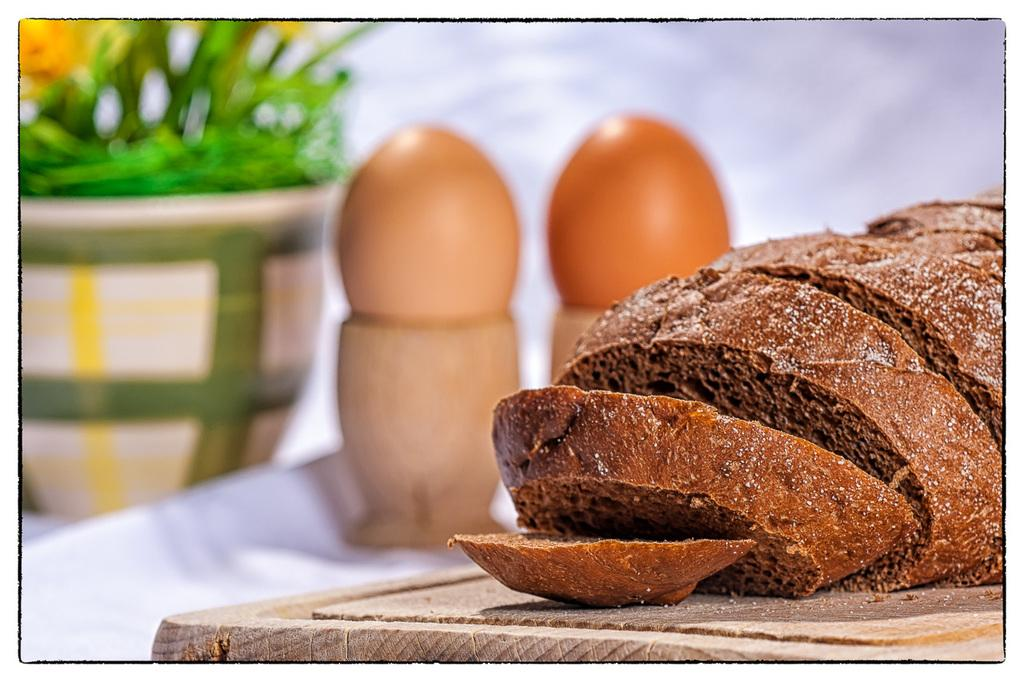What is the main object on the wooden plate in the image? There are slices of bread on the wooden plate in the image. Are there any other food items visible in the image? Yes, there are two eggs on two stands. Can you describe the plant pot in the image? The plant pot is located in the top left corner of the image. What might be used to hold the eggs in place? The two stands are used to hold the eggs in place. What type of goose is playing the trumpet in the image? There is no goose or trumpet present in the image. What is the band doing in the image? There is no band present in the image. 